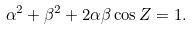<formula> <loc_0><loc_0><loc_500><loc_500>\alpha ^ { 2 } + \beta ^ { 2 } + 2 \alpha \beta \cos Z = 1 .</formula> 